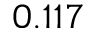<formula> <loc_0><loc_0><loc_500><loc_500>0 . 1 1 7</formula> 